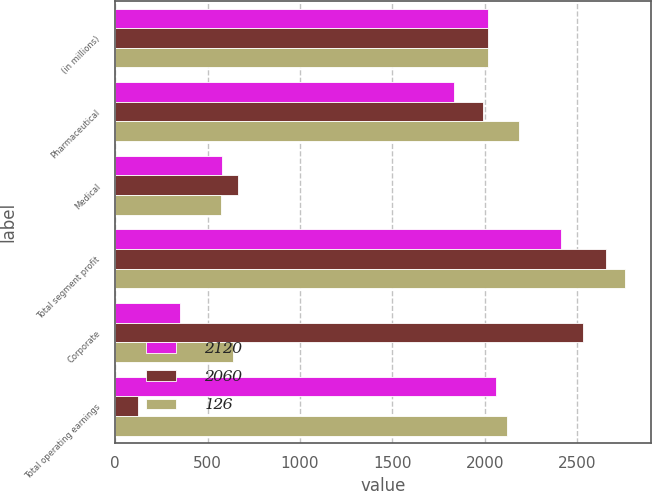Convert chart. <chart><loc_0><loc_0><loc_500><loc_500><stacked_bar_chart><ecel><fcel>(in millions)<fcel>Pharmaceutical<fcel>Medical<fcel>Total segment profit<fcel>Corporate<fcel>Total operating earnings<nl><fcel>2120<fcel>2019<fcel>1834<fcel>576<fcel>2410<fcel>350<fcel>2060<nl><fcel>2060<fcel>2018<fcel>1992<fcel>662<fcel>2654<fcel>2528<fcel>126<nl><fcel>126<fcel>2017<fcel>2187<fcel>572<fcel>2759<fcel>639<fcel>2120<nl></chart> 